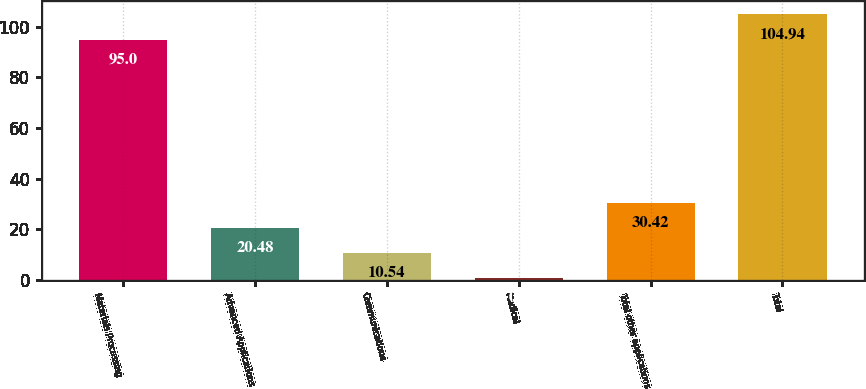<chart> <loc_0><loc_0><loc_500><loc_500><bar_chart><fcel>Materials Processing<fcel>Advanced Applications<fcel>Communications<fcel>Medical<fcel>Total other applications<fcel>Total<nl><fcel>95<fcel>20.48<fcel>10.54<fcel>0.6<fcel>30.42<fcel>104.94<nl></chart> 